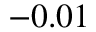Convert formula to latex. <formula><loc_0><loc_0><loc_500><loc_500>- 0 . 0 1</formula> 